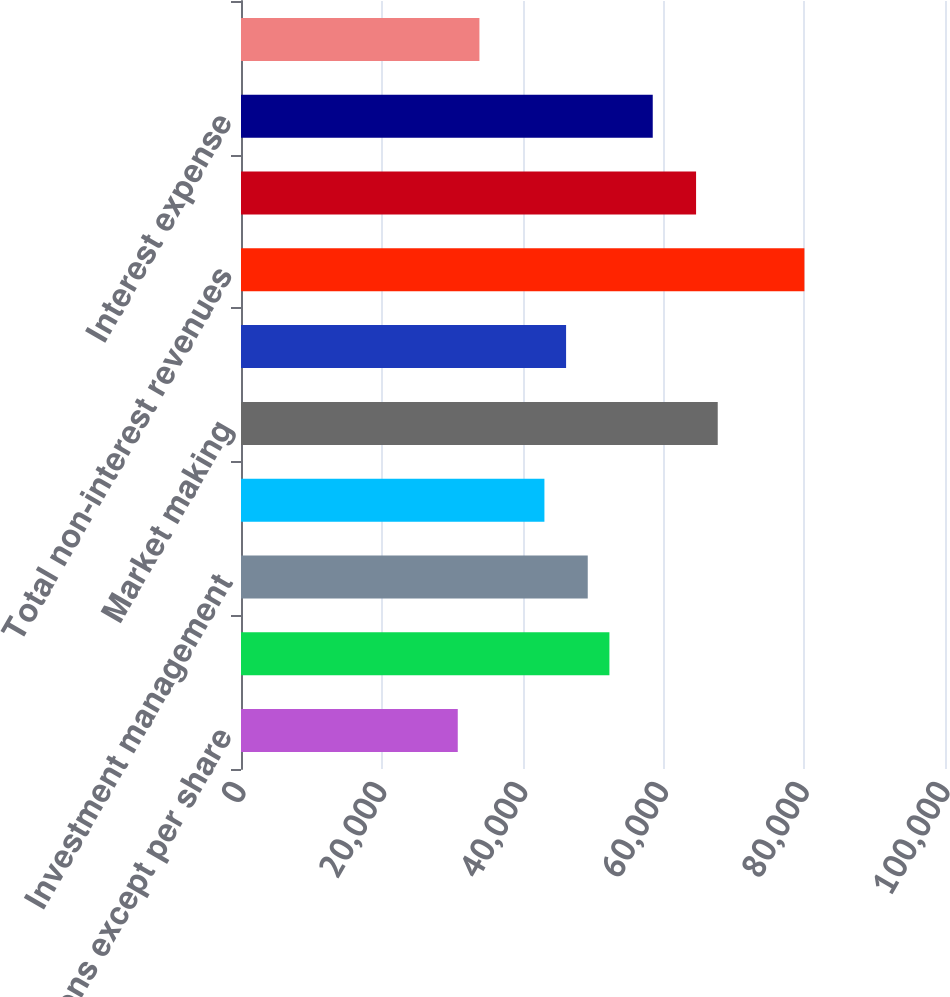Convert chart to OTSL. <chart><loc_0><loc_0><loc_500><loc_500><bar_chart><fcel>in millions except per share<fcel>Investment banking<fcel>Investment management<fcel>Commissions and fees<fcel>Market making<fcel>Other principal transactions<fcel>Total non-interest revenues<fcel>Interest income<fcel>Interest expense<fcel>Net interest income<nl><fcel>30790<fcel>52331.6<fcel>49254.2<fcel>43099.5<fcel>67718.4<fcel>46176.8<fcel>80027.9<fcel>64641.1<fcel>58486.3<fcel>33867.4<nl></chart> 